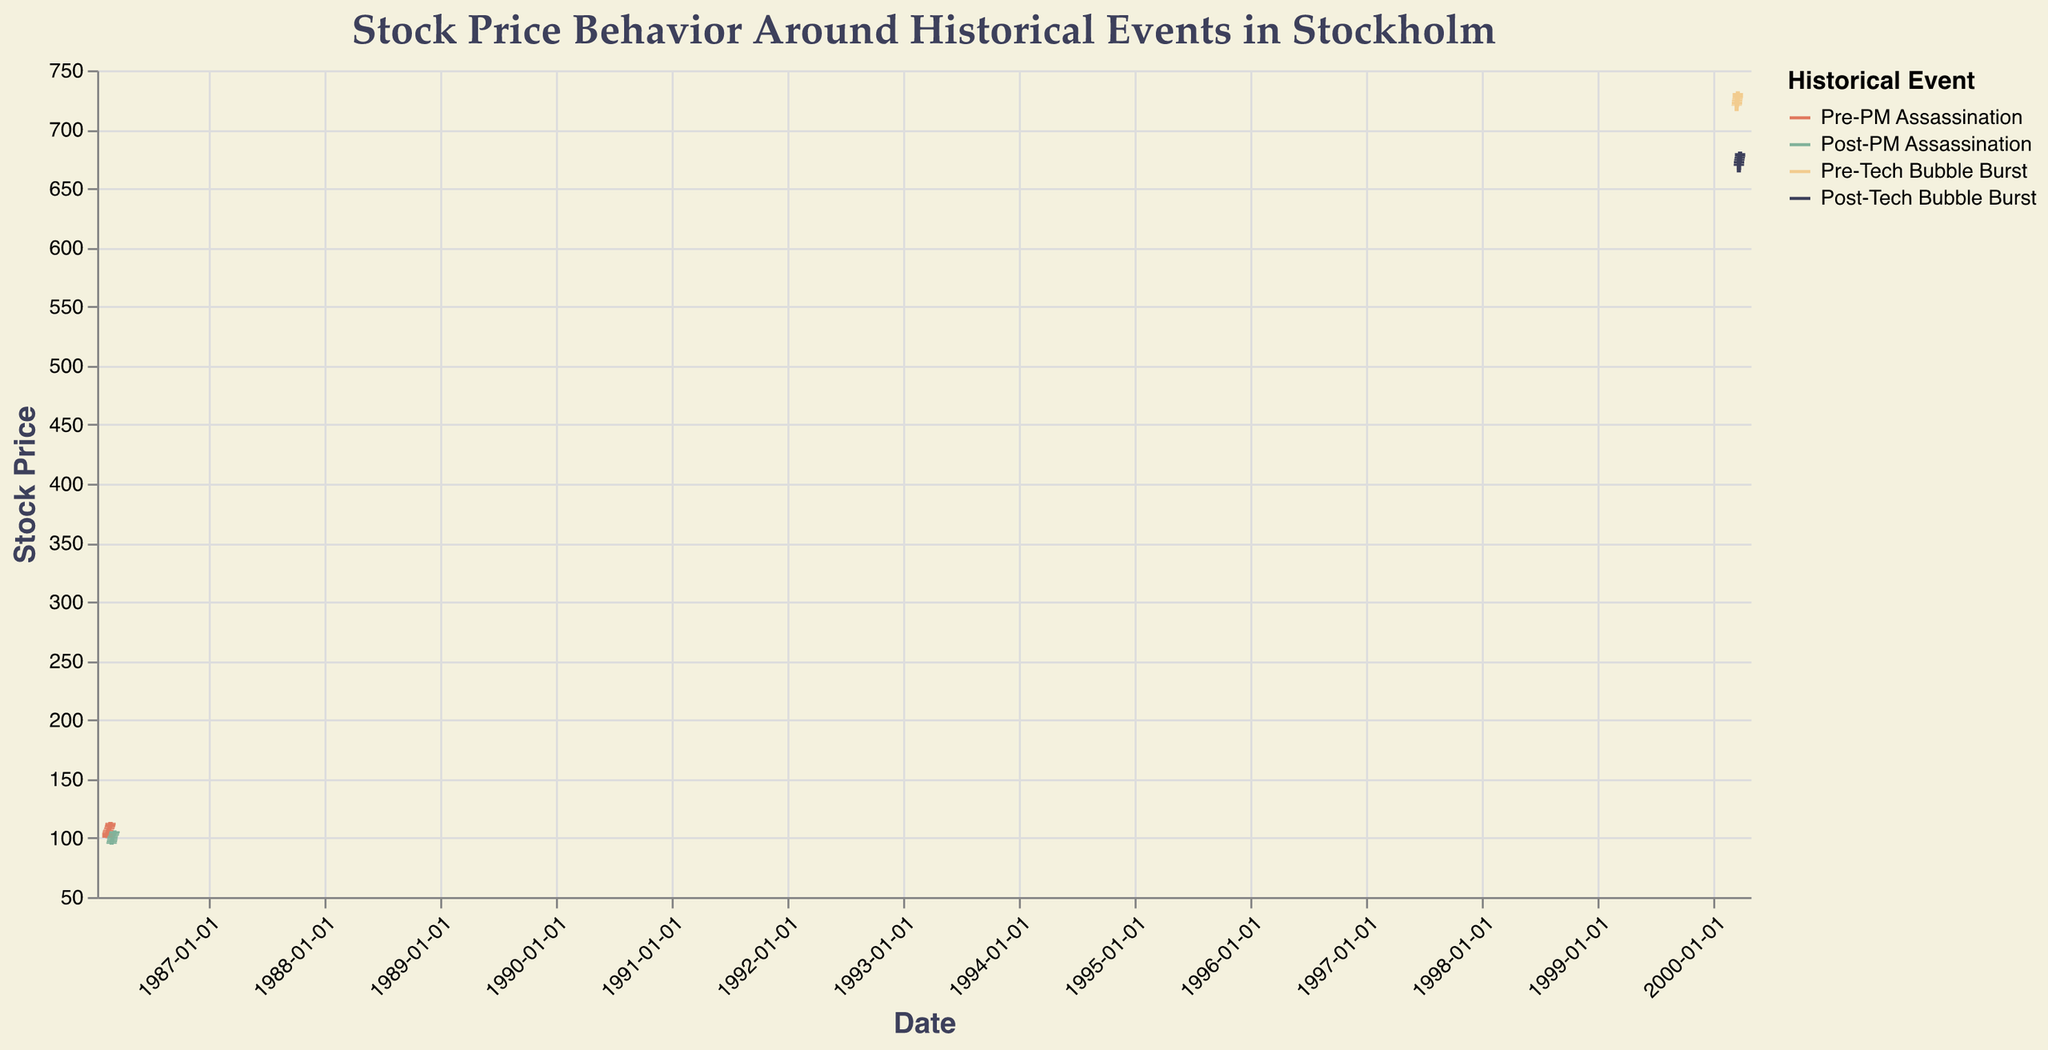What is the title of the figure? The title is located at the top of the figure and gives an overview of what the plot represents: "Stock Price Behavior Around Historical Events in Stockholm".
Answer: Stock Price Behavior Around Historical Events in Stockholm Which event does the stock price reach the highest point and what is that value? By looking at the highest points marked on the y-axis across different event periods in the candlestick plot, the highest value (732.20) is reached during the "Pre-Tech Bubble Burst" on 2000-03-17.
Answer: Pre-Tech Bubble Burst, 732.20 What is the average closing stock price during the Pre-PM Assassination period? Summing up the closing prices during the Pre-PM Assassination dates (104.50, 105.75, 106.80, 107.35, 108.75, 109.30, 110.60, 112.00, 112.90) gives 878.95, and averaging them over 9 days results in 878.95 / 9 = 97.66.
Answer: 97.66 How did the stock price change immediately following the PM Assassination event on 1986-03-03? By looking at the open and close values of the stock on 1986-03-03, it opened at 95.00 and closed at 96.50, showing that the stock declined rapidly from the preceding days and then recovered slightly on the same day to close at 96.50.
Answer: Opened at 95.00 and closed at 96.50 Compare the post-event volume of trades after the PM Assassination and the Tech Bubble Burst. Which had a higher average volume? The volume of trades post-PM Assassination were 2200000, 2100000, 2050000, 1980000, 1930000, 1890000, 1830000, 1770000 and post-Tech Bubble Burst were 3150000, 3200000, 3250000, 3300000, 3350000 giving total volumes of 15640000 (PM Assassination) and 16250000 (Tech Bubble Burst) respectively. Averaging over 8 days for each, the averages are 15640000 / 8 = 1955000 and 16250000 / 8 = 2031250.
Answer: Tech Bubble Burst had a higher average volume What is the significance of the change in stock price on 2000-03-20 compared to the preceding day during Post-Tech Bubble Burst? The stock price dropped from the previous close of 726.50 to an open of 669.00, indicating a major decline symbolizing the bubble burst, which reflects a loss of 57.50 in value.
Answer: Major decline of 57.50 in value What general trend do we observe in stock prices before and after the PM Assassination? Before the PM assassination, stock prices generally exhibit an upward trend, steadily increasing from 100.23 to 112.90. After the assassination, there is a notable drop to 95.00, followed by a gradual recovery.
Answer: Upward trend before, sharp drop followed by recovery after During the Pre-Tech Bubble Burst, what was the closing price trend from 2000-03-13 to 2000-03-17? The closing prices during the Pre-Tech Bubble Burst period were gradually increasing from 720.75 to 730.80 over these five days.
Answer: Increasing trend 